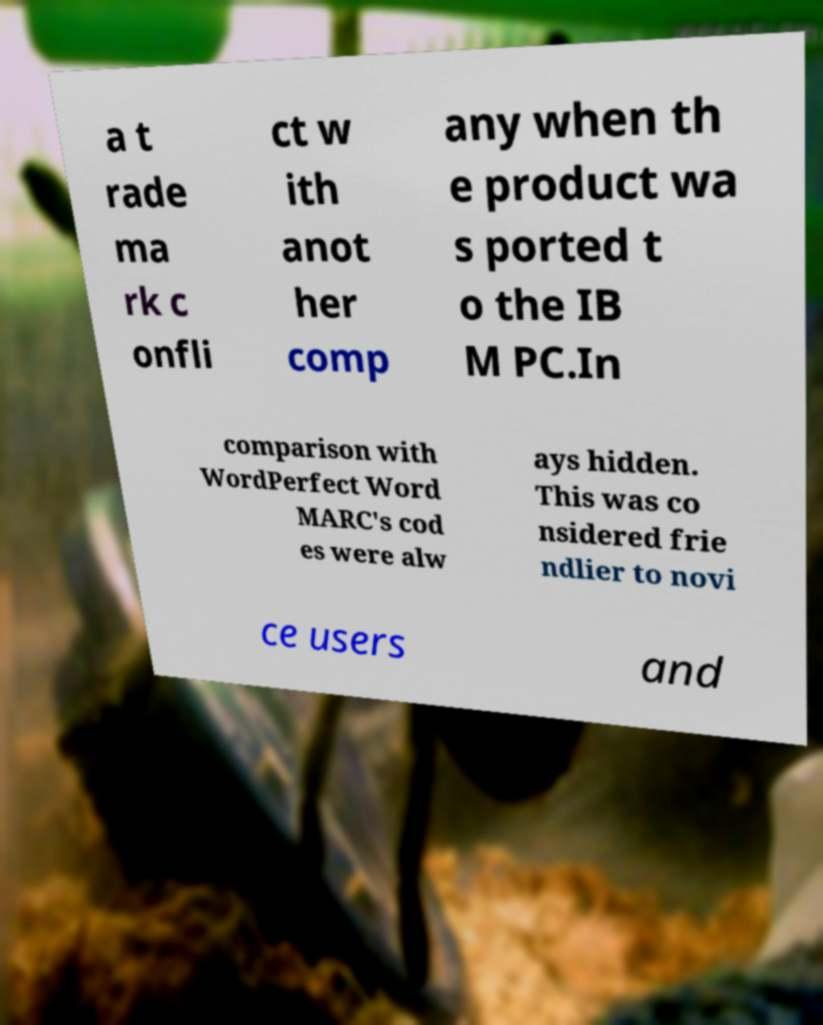What messages or text are displayed in this image? I need them in a readable, typed format. a t rade ma rk c onfli ct w ith anot her comp any when th e product wa s ported t o the IB M PC.In comparison with WordPerfect Word MARC's cod es were alw ays hidden. This was co nsidered frie ndlier to novi ce users and 